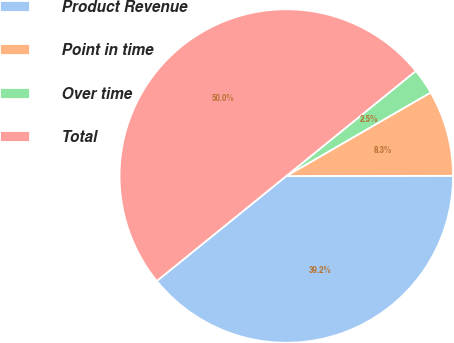Convert chart to OTSL. <chart><loc_0><loc_0><loc_500><loc_500><pie_chart><fcel>Product Revenue<fcel>Point in time<fcel>Over time<fcel>Total<nl><fcel>39.18%<fcel>8.33%<fcel>2.5%<fcel>50.0%<nl></chart> 